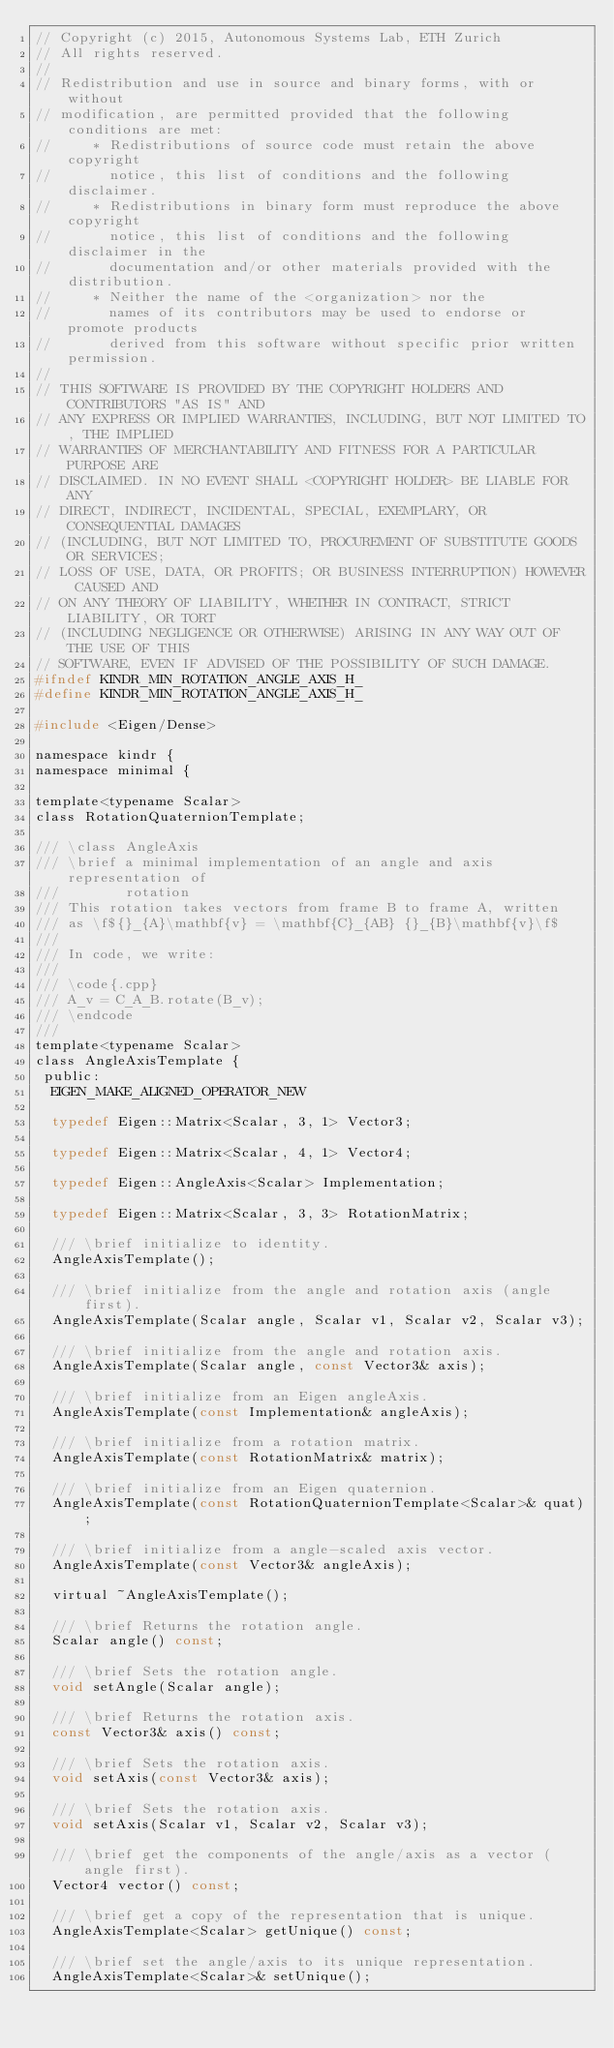<code> <loc_0><loc_0><loc_500><loc_500><_C_>// Copyright (c) 2015, Autonomous Systems Lab, ETH Zurich
// All rights reserved.
// 
// Redistribution and use in source and binary forms, with or without
// modification, are permitted provided that the following conditions are met:
//     * Redistributions of source code must retain the above copyright
//       notice, this list of conditions and the following disclaimer.
//     * Redistributions in binary form must reproduce the above copyright
//       notice, this list of conditions and the following disclaimer in the
//       documentation and/or other materials provided with the distribution.
//     * Neither the name of the <organization> nor the
//       names of its contributors may be used to endorse or promote products
//       derived from this software without specific prior written permission.
// 
// THIS SOFTWARE IS PROVIDED BY THE COPYRIGHT HOLDERS AND CONTRIBUTORS "AS IS" AND
// ANY EXPRESS OR IMPLIED WARRANTIES, INCLUDING, BUT NOT LIMITED TO, THE IMPLIED
// WARRANTIES OF MERCHANTABILITY AND FITNESS FOR A PARTICULAR PURPOSE ARE
// DISCLAIMED. IN NO EVENT SHALL <COPYRIGHT HOLDER> BE LIABLE FOR ANY
// DIRECT, INDIRECT, INCIDENTAL, SPECIAL, EXEMPLARY, OR CONSEQUENTIAL DAMAGES
// (INCLUDING, BUT NOT LIMITED TO, PROCUREMENT OF SUBSTITUTE GOODS OR SERVICES;
// LOSS OF USE, DATA, OR PROFITS; OR BUSINESS INTERRUPTION) HOWEVER CAUSED AND
// ON ANY THEORY OF LIABILITY, WHETHER IN CONTRACT, STRICT LIABILITY, OR TORT
// (INCLUDING NEGLIGENCE OR OTHERWISE) ARISING IN ANY WAY OUT OF THE USE OF THIS
// SOFTWARE, EVEN IF ADVISED OF THE POSSIBILITY OF SUCH DAMAGE.
#ifndef KINDR_MIN_ROTATION_ANGLE_AXIS_H_
#define KINDR_MIN_ROTATION_ANGLE_AXIS_H_

#include <Eigen/Dense>

namespace kindr {
namespace minimal {

template<typename Scalar>
class RotationQuaternionTemplate;

/// \class AngleAxis
/// \brief a minimal implementation of an angle and axis representation of
///        rotation
/// This rotation takes vectors from frame B to frame A, written
/// as \f${}_{A}\mathbf{v} = \mathbf{C}_{AB} {}_{B}\mathbf{v}\f$
///
/// In code, we write:
///
/// \code{.cpp}
/// A_v = C_A_B.rotate(B_v);
/// \endcode
///
template<typename Scalar>
class AngleAxisTemplate {
 public:
  EIGEN_MAKE_ALIGNED_OPERATOR_NEW

  typedef Eigen::Matrix<Scalar, 3, 1> Vector3;
  
  typedef Eigen::Matrix<Scalar, 4, 1> Vector4;

  typedef Eigen::AngleAxis<Scalar> Implementation;

  typedef Eigen::Matrix<Scalar, 3, 3> RotationMatrix;

  /// \brief initialize to identity.
  AngleAxisTemplate();

  /// \brief initialize from the angle and rotation axis (angle first).
  AngleAxisTemplate(Scalar angle, Scalar v1, Scalar v2, Scalar v3);
  
  /// \brief initialize from the angle and rotation axis.
  AngleAxisTemplate(Scalar angle, const Vector3& axis);

  /// \brief initialize from an Eigen angleAxis.
  AngleAxisTemplate(const Implementation& angleAxis);

  /// \brief initialize from a rotation matrix.
  AngleAxisTemplate(const RotationMatrix& matrix);

  /// \brief initialize from an Eigen quaternion.
  AngleAxisTemplate(const RotationQuaternionTemplate<Scalar>& quat);
  
  /// \brief initialize from a angle-scaled axis vector.
  AngleAxisTemplate(const Vector3& angleAxis);

  virtual ~AngleAxisTemplate();

  /// \brief Returns the rotation angle.
  Scalar angle() const;

  /// \brief Sets the rotation angle.
  void setAngle(Scalar angle);

  /// \brief Returns the rotation axis.
  const Vector3& axis() const;

  /// \brief Sets the rotation axis.
  void setAxis(const Vector3& axis);

  /// \brief Sets the rotation axis.
  void setAxis(Scalar v1, Scalar v2, Scalar v3);

  /// \brief get the components of the angle/axis as a vector (angle first).
  Vector4 vector() const;

  /// \brief get a copy of the representation that is unique.
  AngleAxisTemplate<Scalar> getUnique() const;

  /// \brief set the angle/axis to its unique representation.
  AngleAxisTemplate<Scalar>& setUnique();
</code> 